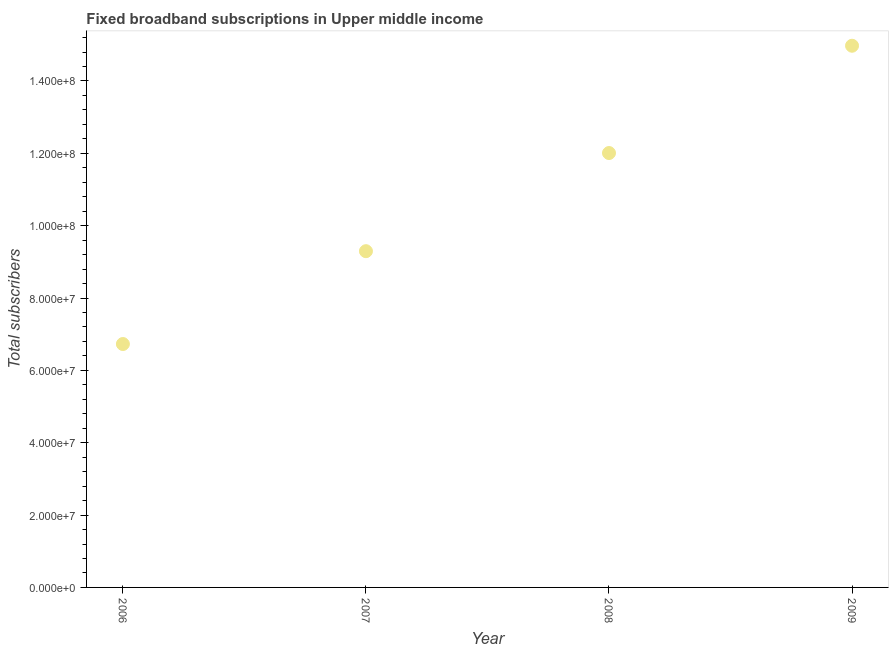What is the total number of fixed broadband subscriptions in 2009?
Keep it short and to the point. 1.50e+08. Across all years, what is the maximum total number of fixed broadband subscriptions?
Offer a terse response. 1.50e+08. Across all years, what is the minimum total number of fixed broadband subscriptions?
Provide a succinct answer. 6.73e+07. In which year was the total number of fixed broadband subscriptions minimum?
Your answer should be compact. 2006. What is the sum of the total number of fixed broadband subscriptions?
Your response must be concise. 4.30e+08. What is the difference between the total number of fixed broadband subscriptions in 2007 and 2008?
Give a very brief answer. -2.71e+07. What is the average total number of fixed broadband subscriptions per year?
Give a very brief answer. 1.08e+08. What is the median total number of fixed broadband subscriptions?
Make the answer very short. 1.07e+08. What is the ratio of the total number of fixed broadband subscriptions in 2006 to that in 2008?
Your answer should be very brief. 0.56. What is the difference between the highest and the second highest total number of fixed broadband subscriptions?
Provide a short and direct response. 2.97e+07. What is the difference between the highest and the lowest total number of fixed broadband subscriptions?
Provide a short and direct response. 8.25e+07. Does the total number of fixed broadband subscriptions monotonically increase over the years?
Your response must be concise. Yes. How many years are there in the graph?
Offer a terse response. 4. Are the values on the major ticks of Y-axis written in scientific E-notation?
Provide a succinct answer. Yes. What is the title of the graph?
Make the answer very short. Fixed broadband subscriptions in Upper middle income. What is the label or title of the Y-axis?
Your answer should be very brief. Total subscribers. What is the Total subscribers in 2006?
Make the answer very short. 6.73e+07. What is the Total subscribers in 2007?
Your response must be concise. 9.30e+07. What is the Total subscribers in 2008?
Your answer should be compact. 1.20e+08. What is the Total subscribers in 2009?
Your answer should be compact. 1.50e+08. What is the difference between the Total subscribers in 2006 and 2007?
Keep it short and to the point. -2.57e+07. What is the difference between the Total subscribers in 2006 and 2008?
Give a very brief answer. -5.28e+07. What is the difference between the Total subscribers in 2006 and 2009?
Provide a short and direct response. -8.25e+07. What is the difference between the Total subscribers in 2007 and 2008?
Provide a succinct answer. -2.71e+07. What is the difference between the Total subscribers in 2007 and 2009?
Provide a succinct answer. -5.68e+07. What is the difference between the Total subscribers in 2008 and 2009?
Offer a very short reply. -2.97e+07. What is the ratio of the Total subscribers in 2006 to that in 2007?
Provide a short and direct response. 0.72. What is the ratio of the Total subscribers in 2006 to that in 2008?
Offer a very short reply. 0.56. What is the ratio of the Total subscribers in 2006 to that in 2009?
Make the answer very short. 0.45. What is the ratio of the Total subscribers in 2007 to that in 2008?
Give a very brief answer. 0.77. What is the ratio of the Total subscribers in 2007 to that in 2009?
Your answer should be very brief. 0.62. What is the ratio of the Total subscribers in 2008 to that in 2009?
Make the answer very short. 0.8. 